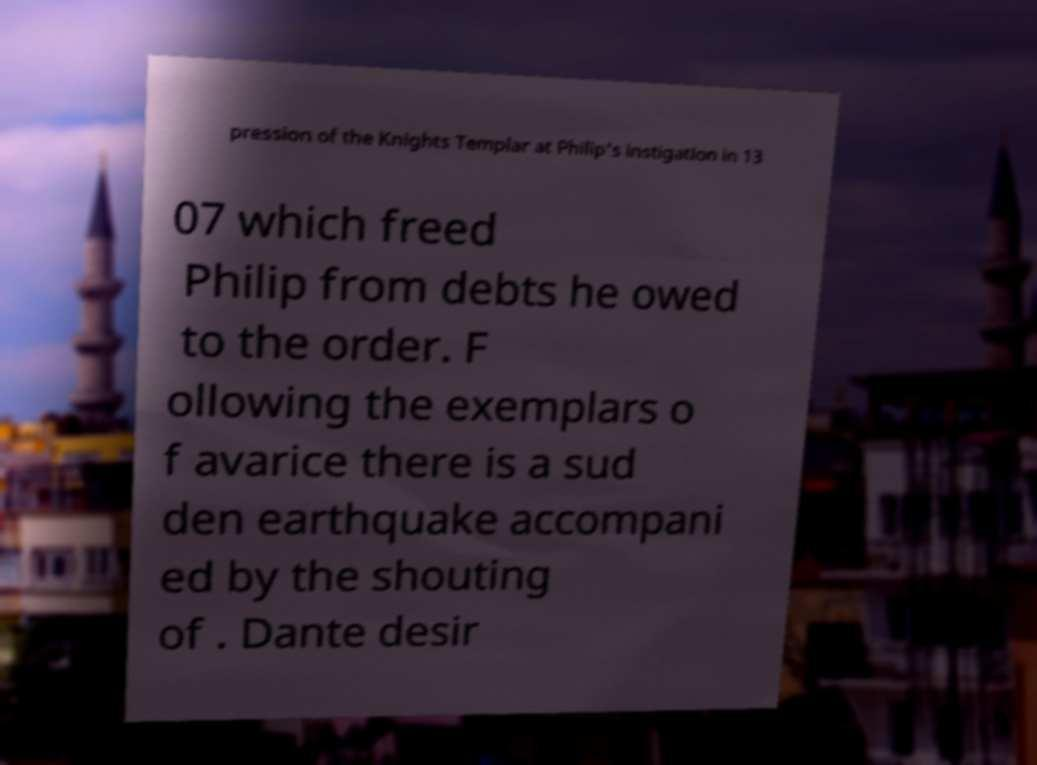For documentation purposes, I need the text within this image transcribed. Could you provide that? pression of the Knights Templar at Philip's instigation in 13 07 which freed Philip from debts he owed to the order. F ollowing the exemplars o f avarice there is a sud den earthquake accompani ed by the shouting of . Dante desir 